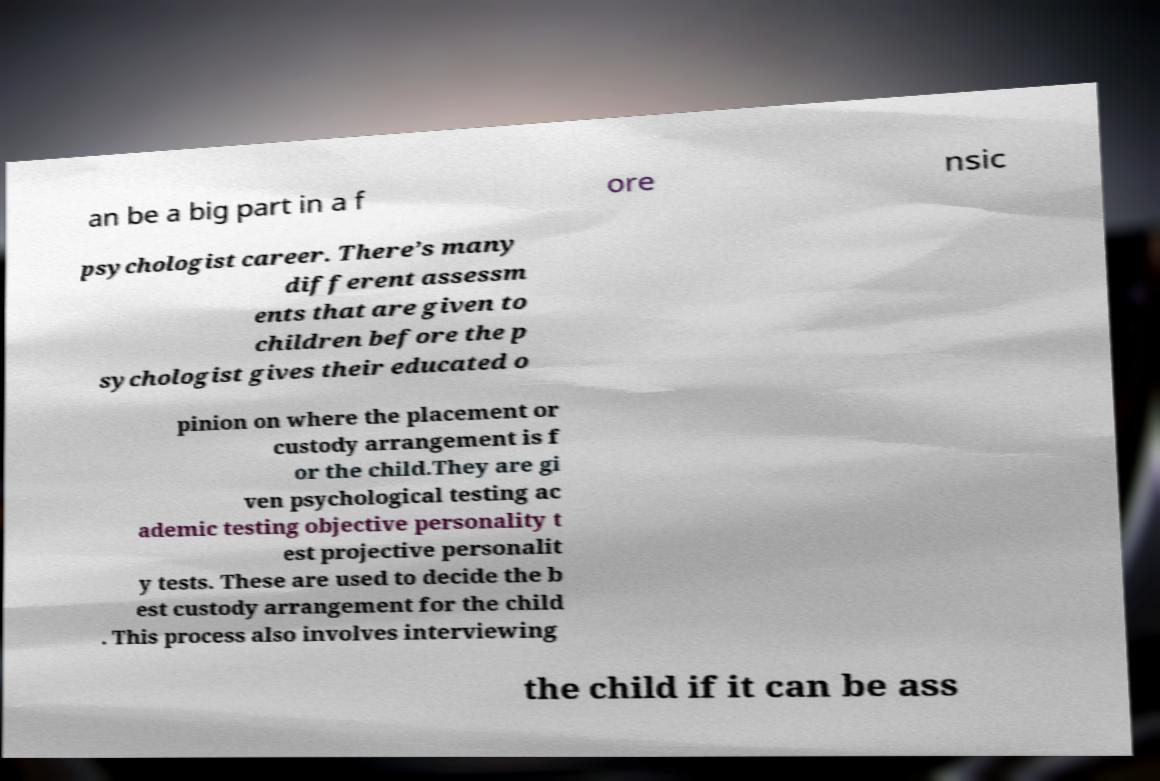Please read and relay the text visible in this image. What does it say? an be a big part in a f ore nsic psychologist career. There’s many different assessm ents that are given to children before the p sychologist gives their educated o pinion on where the placement or custody arrangement is f or the child.They are gi ven psychological testing ac ademic testing objective personality t est projective personalit y tests. These are used to decide the b est custody arrangement for the child . This process also involves interviewing the child if it can be ass 